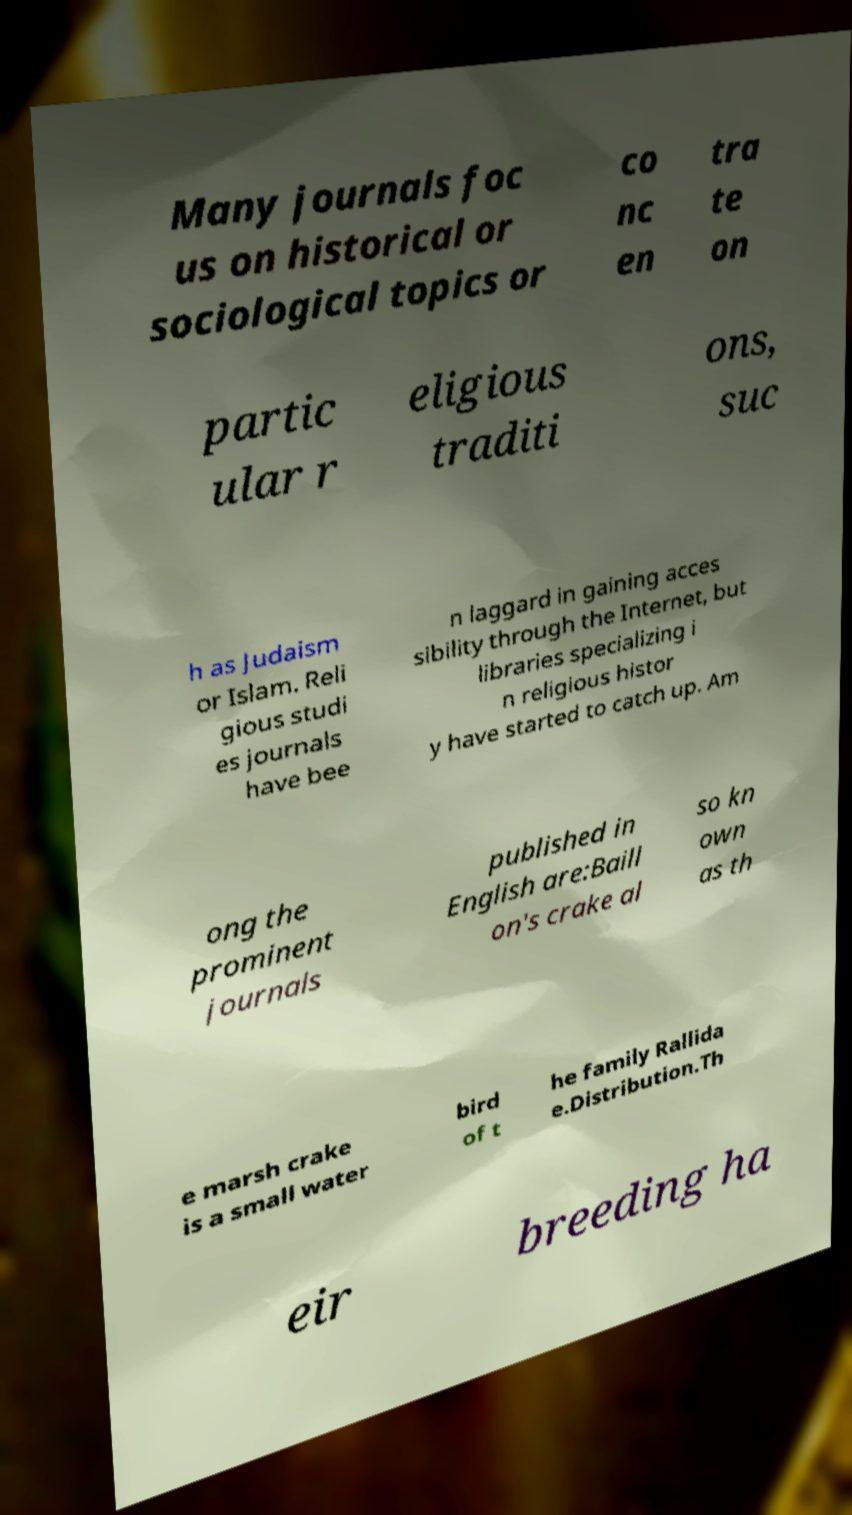Please identify and transcribe the text found in this image. Many journals foc us on historical or sociological topics or co nc en tra te on partic ular r eligious traditi ons, suc h as Judaism or Islam. Reli gious studi es journals have bee n laggard in gaining acces sibility through the Internet, but libraries specializing i n religious histor y have started to catch up. Am ong the prominent journals published in English are:Baill on's crake al so kn own as th e marsh crake is a small water bird of t he family Rallida e.Distribution.Th eir breeding ha 